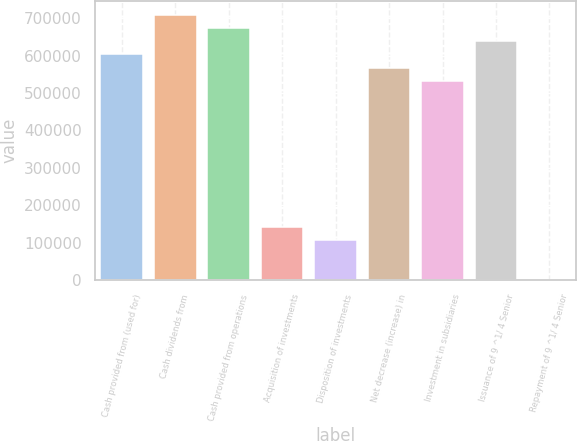Convert chart. <chart><loc_0><loc_0><loc_500><loc_500><bar_chart><fcel>Cash provided from (used for)<fcel>Cash dividends from<fcel>Cash provided from operations<fcel>Acquisition of investments<fcel>Disposition of investments<fcel>Net decrease (increase) in<fcel>Investment in subsidiaries<fcel>Issuance of 9 ^1/ 4 Senior<fcel>Repayment of 9 ^1/ 4 Senior<nl><fcel>602981<fcel>709390<fcel>673920<fcel>141878<fcel>106409<fcel>567512<fcel>532042<fcel>638451<fcel>0.28<nl></chart> 